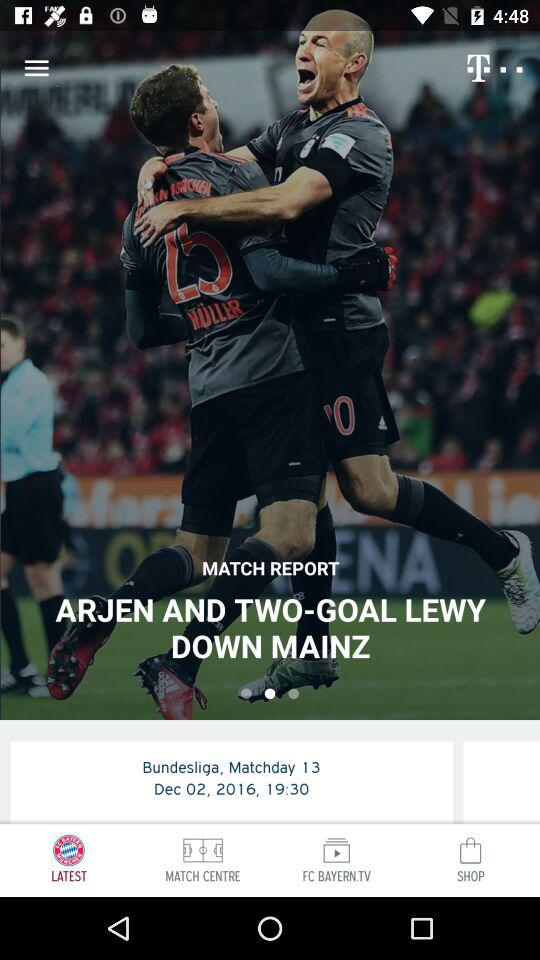What is the date of the match? The date of the match is December 02, 2016. 